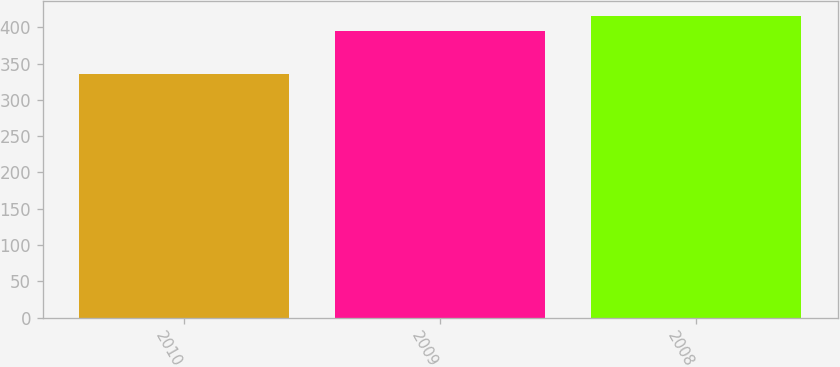Convert chart to OTSL. <chart><loc_0><loc_0><loc_500><loc_500><bar_chart><fcel>2010<fcel>2009<fcel>2008<nl><fcel>335<fcel>395<fcel>416<nl></chart> 